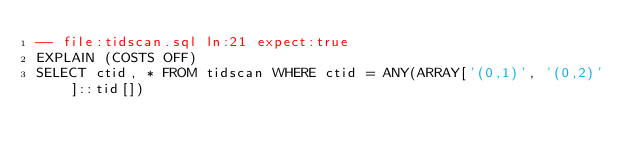Convert code to text. <code><loc_0><loc_0><loc_500><loc_500><_SQL_>-- file:tidscan.sql ln:21 expect:true
EXPLAIN (COSTS OFF)
SELECT ctid, * FROM tidscan WHERE ctid = ANY(ARRAY['(0,1)', '(0,2)']::tid[])
</code> 